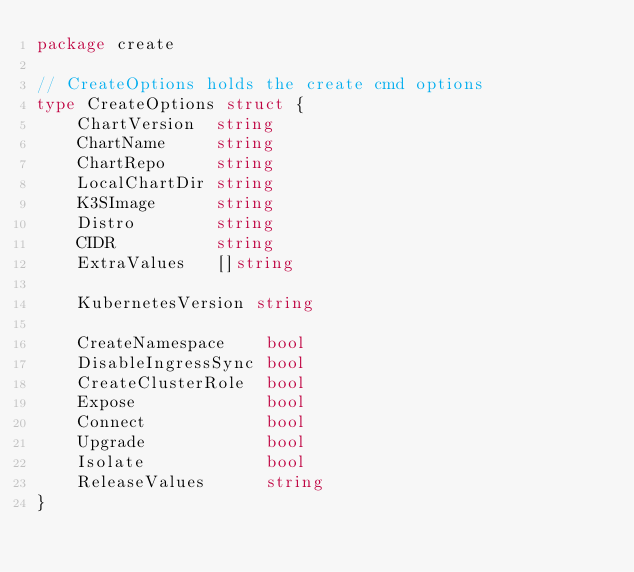<code> <loc_0><loc_0><loc_500><loc_500><_Go_>package create

// CreateOptions holds the create cmd options
type CreateOptions struct {
	ChartVersion  string
	ChartName     string
	ChartRepo     string
	LocalChartDir string
	K3SImage      string
	Distro        string
	CIDR          string
	ExtraValues   []string

	KubernetesVersion string

	CreateNamespace    bool
	DisableIngressSync bool
	CreateClusterRole  bool
	Expose             bool
	Connect            bool
	Upgrade            bool
	Isolate            bool
	ReleaseValues      string
}
</code> 